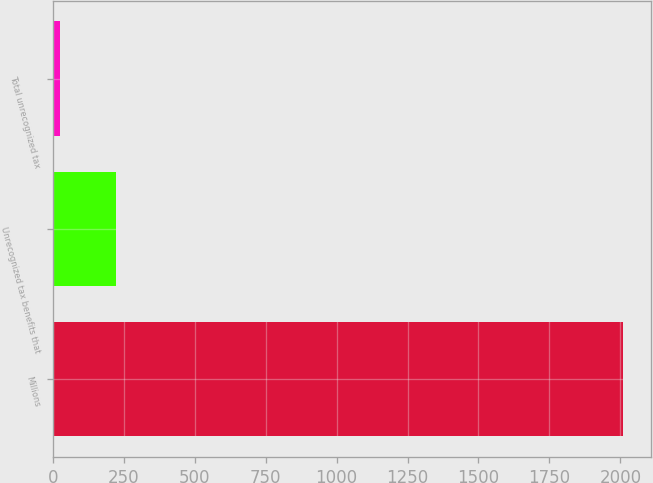<chart> <loc_0><loc_0><loc_500><loc_500><bar_chart><fcel>Millions<fcel>Unrecognized tax benefits that<fcel>Total unrecognized tax<nl><fcel>2008<fcel>224.2<fcel>26<nl></chart> 